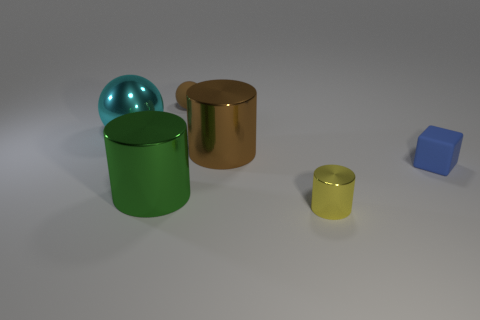How many other things are there of the same color as the small rubber ball?
Your response must be concise. 1. Is there anything else that has the same shape as the big brown object?
Give a very brief answer. Yes. Are there an equal number of metallic things on the left side of the tiny yellow cylinder and green shiny cylinders?
Give a very brief answer. No. There is a small block; is it the same color as the big shiny object right of the tiny brown ball?
Give a very brief answer. No. What is the color of the tiny object that is both to the left of the small rubber block and behind the big green cylinder?
Give a very brief answer. Brown. How many big green metallic objects are left of the thing in front of the green metallic object?
Your answer should be compact. 1. Is there a tiny yellow thing that has the same shape as the green object?
Ensure brevity in your answer.  Yes. Do the big metal object that is in front of the small blue cube and the big shiny thing to the right of the large green metal object have the same shape?
Offer a very short reply. Yes. What number of things are either brown cylinders or matte cylinders?
Your response must be concise. 1. There is a green metal thing that is the same shape as the big brown metallic object; what is its size?
Offer a very short reply. Large. 